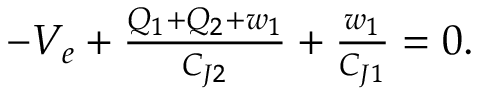<formula> <loc_0><loc_0><loc_500><loc_500>\begin{array} { r } { - V _ { e } + \frac { Q _ { 1 } + Q _ { 2 } + w _ { 1 } } { C _ { J 2 } } + \frac { w _ { 1 } } { C _ { J 1 } } = 0 . } \end{array}</formula> 